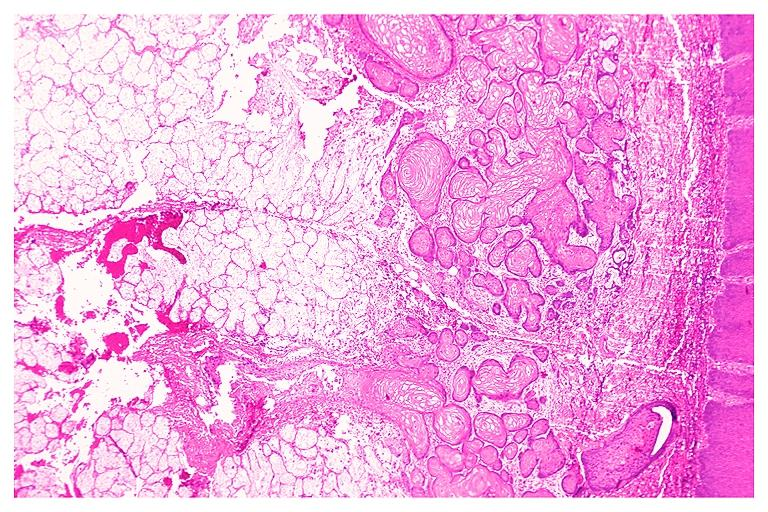does this image show necrotizing sialometaplasia?
Answer the question using a single word or phrase. Yes 